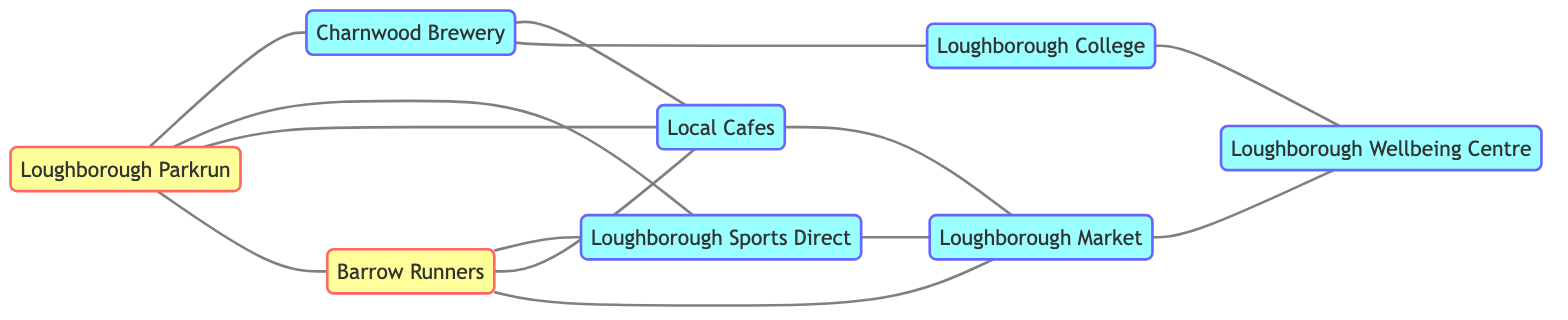What is the total number of nodes in the diagram? The diagram lists a total of eight distinct nodes: Loughborough Parkrun, Charnwood Brewery, Loughborough Sports Direct, Barrow Runners, Loughborough College, Local Cafes, Loughborough Market, and Loughborough Wellbeing Centre. Therefore, counting all these nodes gives us eight.
Answer: 8 Which event is directly connected to Loughborough Parkrun? Looking at the edges in the diagram, Loughborough Parkrun has direct connections to Charnwood Brewery, Loughborough Sports Direct, Local Cafes, and Barrow Runners. Therefore, any of these could be the answer.
Answer: Charnwood Brewery, Loughborough Sports Direct, Local Cafes, Barrow Runners How many business nodes are connected to Loughborough Market? Reviewing the connections from Loughborough Market, the only business node directly connected to it is Local Cafes, and it is also connected to Barrow Runners, which is an event. Therefore, considering only business nodes, there’s one connection.
Answer: 1 Which community event connects to the most businesses directly? Analyzing the edges, Barrow Runners connects to three businesses: Loughborough Sports Direct, Local Cafes, and Loughborough Market. Since no other event connects to more than two businesses, Barrow Runners has the most connections.
Answer: Barrow Runners What is the relationship between Charnwood Brewery and Loughborough College? The diagram indicates that Charnwood Brewery has a direct connection with Loughborough College, meaning they are both linked. Thus, we can describe their relationship as directly connected.
Answer: Directly connected Which node has the least number of connections? By checking the edges connected to each node, Loughborough Wellbeing Centre has only one connection, which is with Loughborough College. Therefore, it has the least connections.
Answer: Loughborough Wellbeing Centre How many edges are present in this diagram? The total count of edges can be identified by reviewing all the unique connections listed. Upon counting, there are twelve edges that connect the nodes.
Answer: 12 Which business is connected to both Loughborough Parkrun and Local Cafes? Upon checking the connections, Loughborough Sports Direct is connected to both Loughborough Parkrun and Local Cafes, fulfilling the requirement of being linked to both.
Answer: Loughborough Sports Direct 